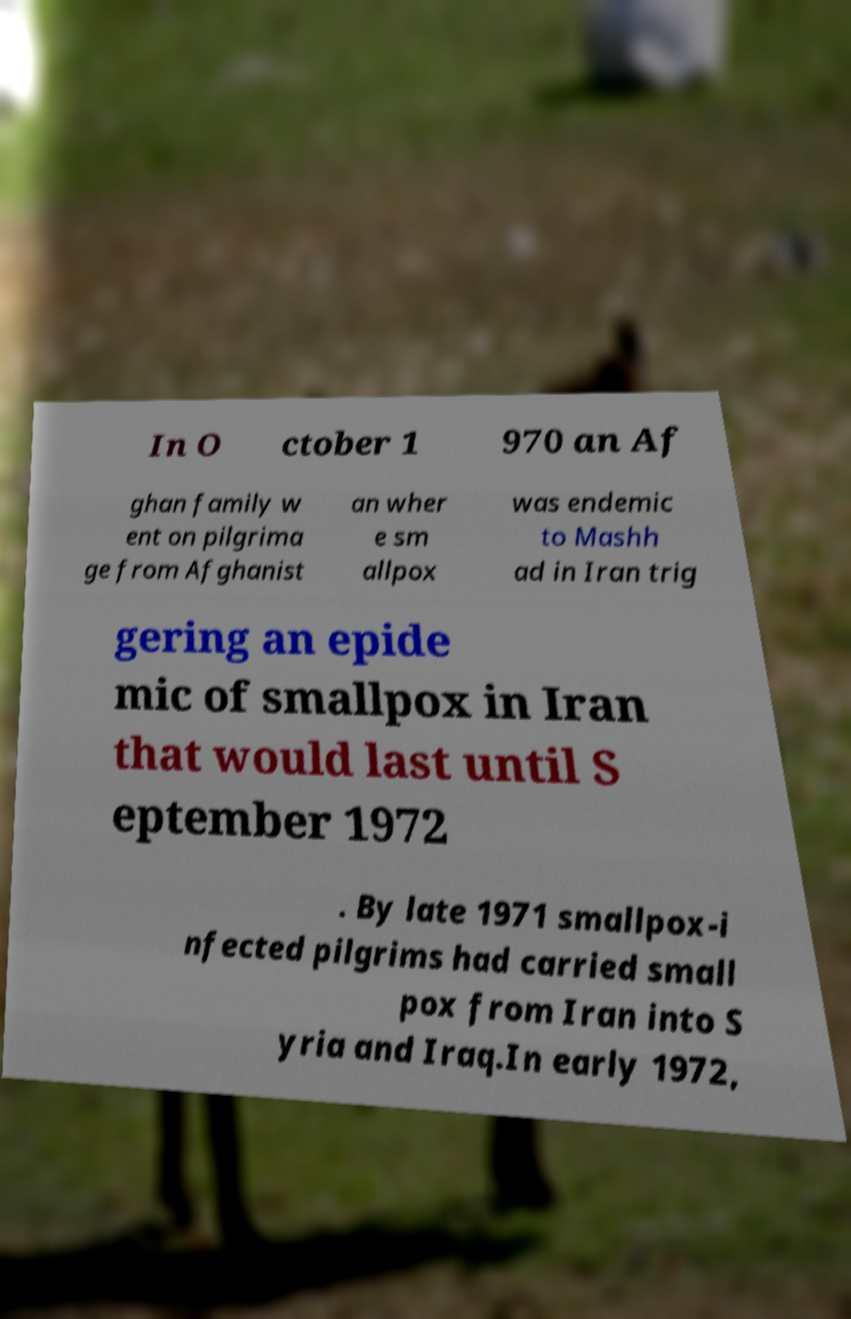There's text embedded in this image that I need extracted. Can you transcribe it verbatim? In O ctober 1 970 an Af ghan family w ent on pilgrima ge from Afghanist an wher e sm allpox was endemic to Mashh ad in Iran trig gering an epide mic of smallpox in Iran that would last until S eptember 1972 . By late 1971 smallpox-i nfected pilgrims had carried small pox from Iran into S yria and Iraq.In early 1972, 